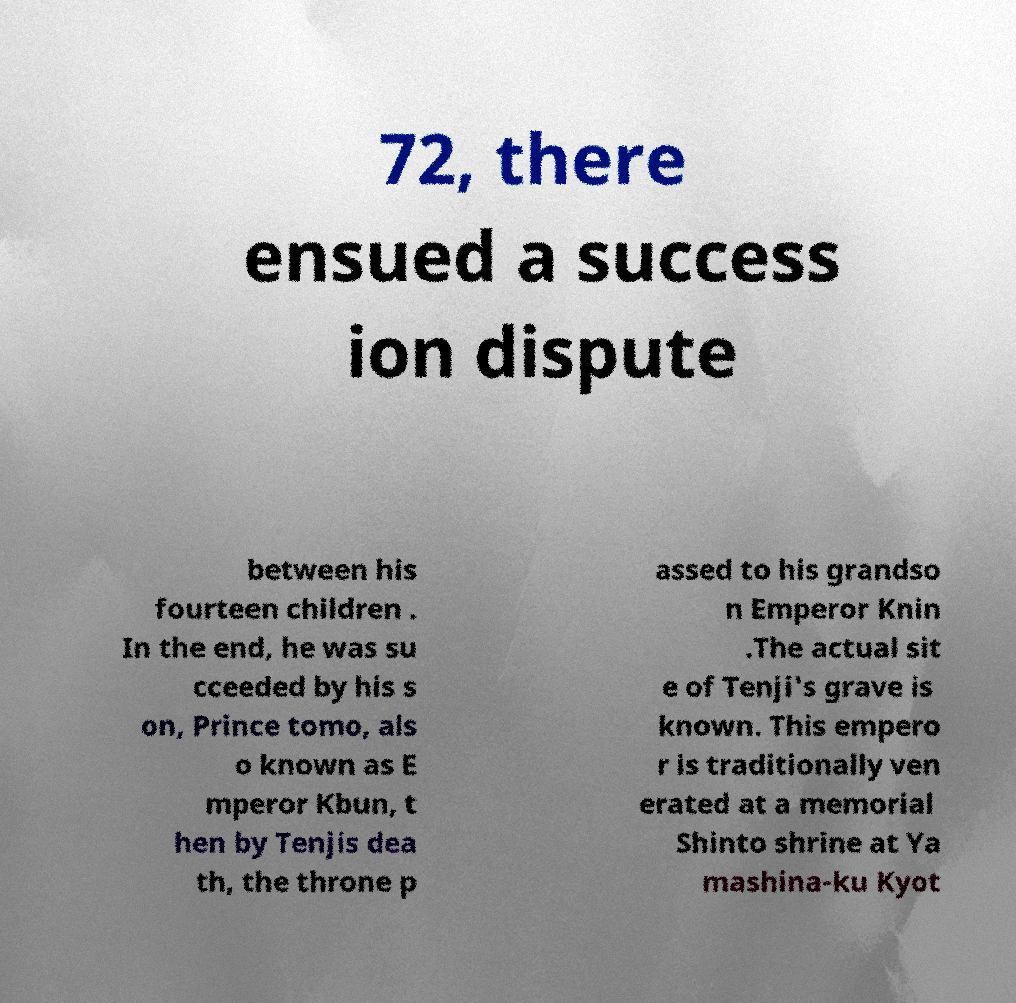Please identify and transcribe the text found in this image. 72, there ensued a success ion dispute between his fourteen children . In the end, he was su cceeded by his s on, Prince tomo, als o known as E mperor Kbun, t hen by Tenjis dea th, the throne p assed to his grandso n Emperor Knin .The actual sit e of Tenji's grave is known. This empero r is traditionally ven erated at a memorial Shinto shrine at Ya mashina-ku Kyot 